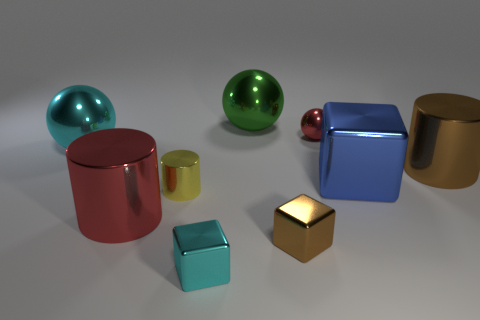There is a brown thing that is the same shape as the small cyan shiny thing; what is its size?
Provide a succinct answer. Small. Does the large block have the same material as the tiny cube that is right of the green metal ball?
Offer a very short reply. Yes. What number of things are small yellow metal cylinders or large brown things?
Make the answer very short. 2. There is a cube that is behind the tiny yellow cylinder; is its size the same as the red thing in front of the small yellow shiny thing?
Offer a very short reply. Yes. What number of cylinders are big cyan things or small red things?
Ensure brevity in your answer.  0. Is there a tiny cyan matte block?
Offer a very short reply. No. How many objects are things that are right of the yellow metal cylinder or blue matte cubes?
Provide a short and direct response. 6. There is a tiny metallic object that is behind the big shiny cylinder right of the small brown cube; what number of small cubes are behind it?
Make the answer very short. 0. There is a red metal thing that is right of the large metallic sphere that is behind the sphere that is to the left of the large green shiny thing; what shape is it?
Make the answer very short. Sphere. How many other objects are there of the same color as the tiny metal ball?
Offer a very short reply. 1. 